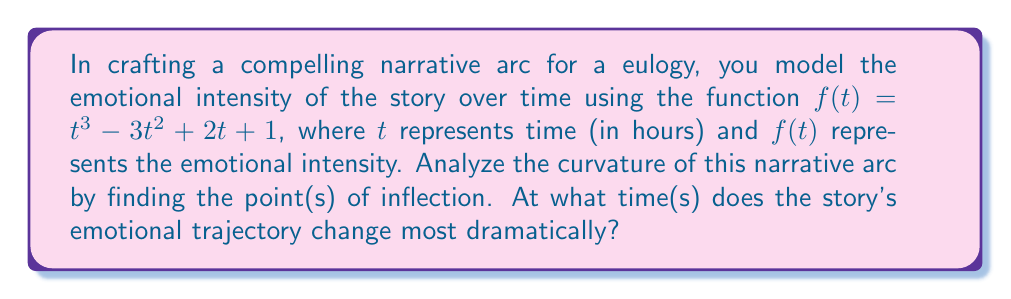Can you answer this question? To find the point(s) of inflection, we need to follow these steps:

1) The curvature of a function changes at points where its second derivative is zero or undefined. These are potential points of inflection.

2) First, let's find the first derivative:
   $f'(t) = 3t^2 - 6t + 2$

3) Now, let's find the second derivative:
   $f''(t) = 6t - 6$

4) Set the second derivative equal to zero and solve for t:
   $6t - 6 = 0$
   $6t = 6$
   $t = 1$

5) To confirm this is a point of inflection, we need to check if the second derivative changes sign at this point:
   
   When $t < 1$, $f''(t) < 0$
   When $t > 1$, $f''(t) > 0$

   The second derivative does change sign at $t = 1$, confirming it's a point of inflection.

6) Therefore, the point of inflection occurs at $t = 1$ hour.

This means that at 1 hour into the narrative, the emotional intensity of the story changes most dramatically, transitioning from accelerating to decelerating or vice versa.
Answer: $t = 1$ hour 